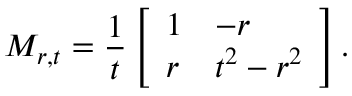Convert formula to latex. <formula><loc_0><loc_0><loc_500><loc_500>M _ { r , t } = \frac { 1 } { t } \left [ \begin{array} { l l } { 1 } & { - r } \\ { r } & { t ^ { 2 } - r ^ { 2 } } \end{array} \right ] .</formula> 